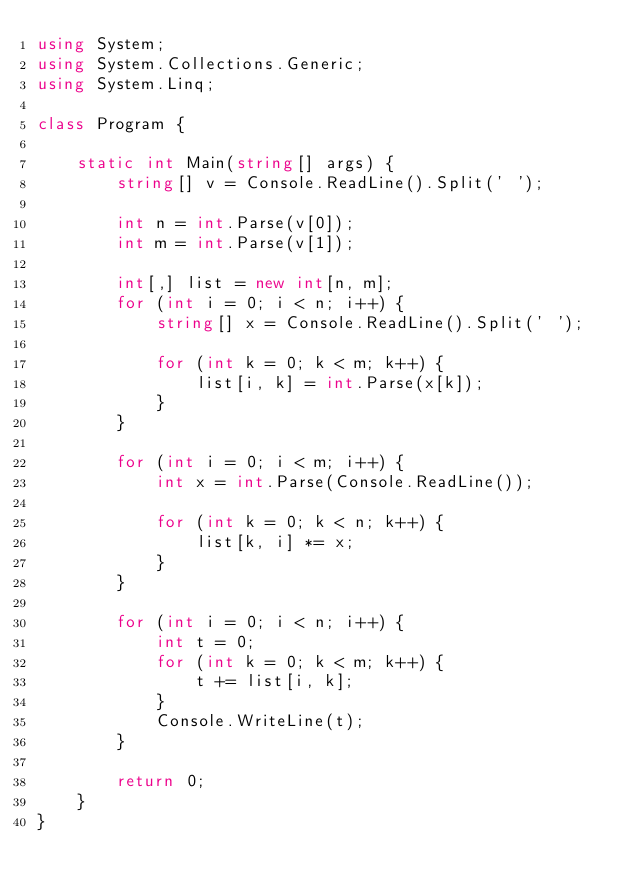<code> <loc_0><loc_0><loc_500><loc_500><_C#_>using System;
using System.Collections.Generic;
using System.Linq;

class Program {

    static int Main(string[] args) {
        string[] v = Console.ReadLine().Split(' ');

        int n = int.Parse(v[0]);
        int m = int.Parse(v[1]);

        int[,] list = new int[n, m];
        for (int i = 0; i < n; i++) {
            string[] x = Console.ReadLine().Split(' ');

            for (int k = 0; k < m; k++) {
                list[i, k] = int.Parse(x[k]);
            }
        }

        for (int i = 0; i < m; i++) {
            int x = int.Parse(Console.ReadLine());

            for (int k = 0; k < n; k++) {
                list[k, i] *= x;
            }
        }

        for (int i = 0; i < n; i++) {
            int t = 0;
            for (int k = 0; k < m; k++) {
                t += list[i, k];
            }
            Console.WriteLine(t);
        }

        return 0;
    }
}
</code> 